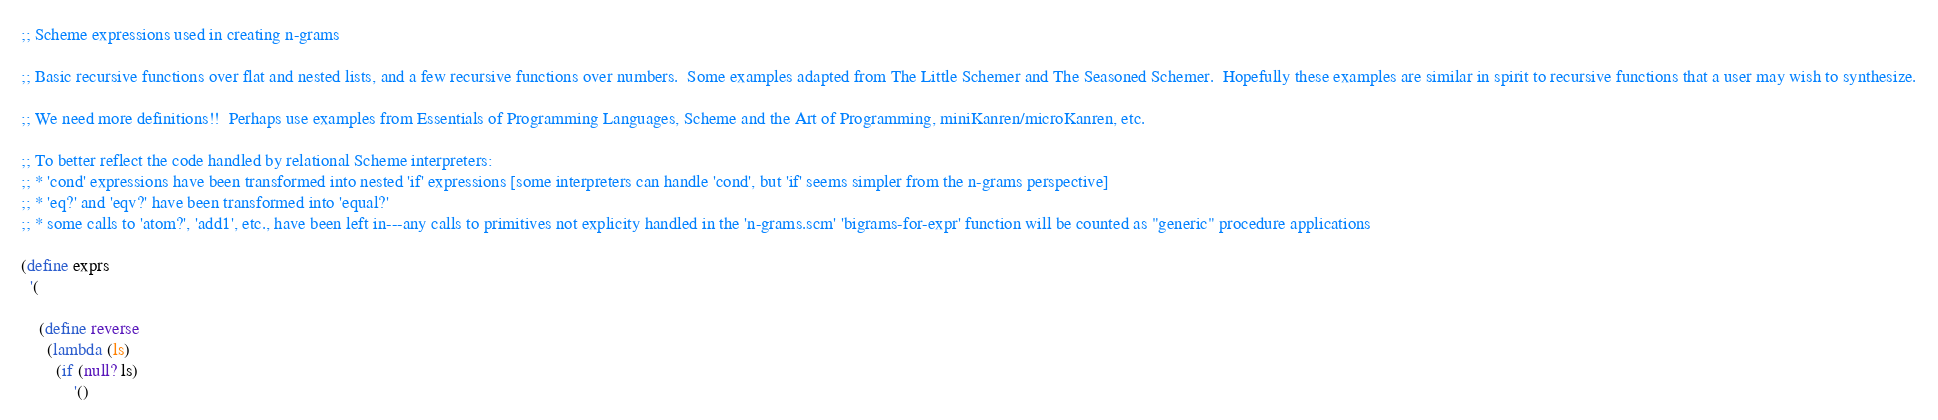<code> <loc_0><loc_0><loc_500><loc_500><_Scheme_>;; Scheme expressions used in creating n-grams

;; Basic recursive functions over flat and nested lists, and a few recursive functions over numbers.  Some examples adapted from The Little Schemer and The Seasoned Schemer.  Hopefully these examples are similar in spirit to recursive functions that a user may wish to synthesize.

;; We need more definitions!!  Perhaps use examples from Essentials of Programming Languages, Scheme and the Art of Programming, miniKanren/microKanren, etc.

;; To better reflect the code handled by relational Scheme interpreters:
;; * 'cond' expressions have been transformed into nested 'if' expressions [some interpreters can handle 'cond', but 'if' seems simpler from the n-grams perspective]
;; * 'eq?' and 'eqv?' have been transformed into 'equal?'
;; * some calls to 'atom?', 'add1', etc., have been left in---any calls to primitives not explicity handled in the 'n-grams.scm' 'bigrams-for-expr' function will be counted as "generic" procedure applications

(define exprs
  '(

    (define reverse
      (lambda (ls)
        (if (null? ls)
            '()</code> 